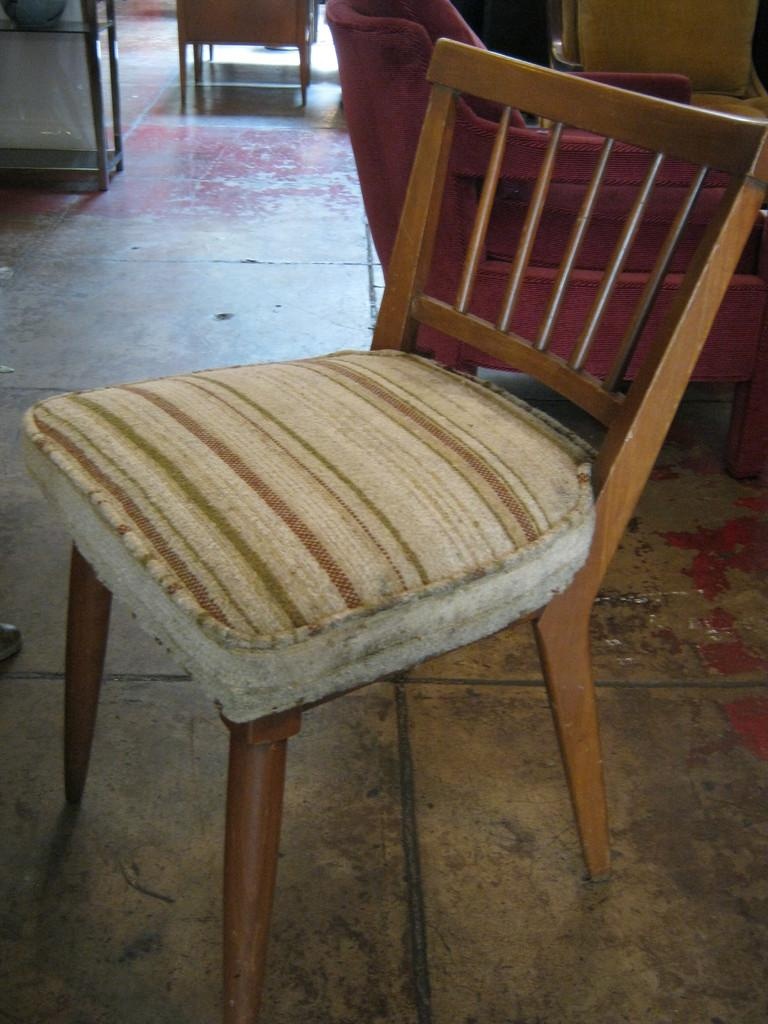What type of furniture is located in the front of the image? There is a chair in the front of the image. What other furniture can be seen in the image? There is a sofa set in the image. Where is the sofa set positioned in the image? The sofa set is on the floor. What type of disease is the doctor treating in the image? There is no doctor or disease present in the image; it only features a chair and a sofa set. 